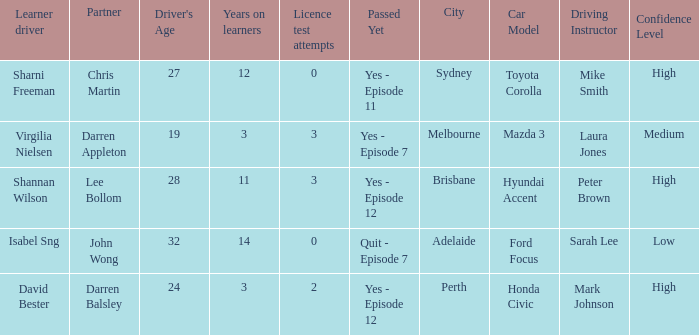Which driver is older than 24 and has more than 0 licence test attempts? Shannan Wilson. 